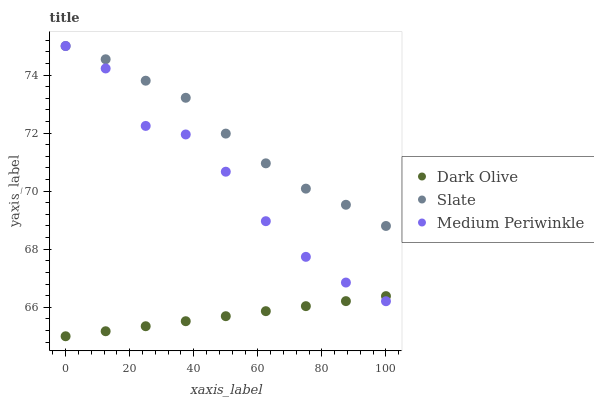Does Dark Olive have the minimum area under the curve?
Answer yes or no. Yes. Does Slate have the maximum area under the curve?
Answer yes or no. Yes. Does Medium Periwinkle have the minimum area under the curve?
Answer yes or no. No. Does Medium Periwinkle have the maximum area under the curve?
Answer yes or no. No. Is Dark Olive the smoothest?
Answer yes or no. Yes. Is Medium Periwinkle the roughest?
Answer yes or no. Yes. Is Medium Periwinkle the smoothest?
Answer yes or no. No. Is Dark Olive the roughest?
Answer yes or no. No. Does Dark Olive have the lowest value?
Answer yes or no. Yes. Does Medium Periwinkle have the lowest value?
Answer yes or no. No. Does Medium Periwinkle have the highest value?
Answer yes or no. Yes. Does Dark Olive have the highest value?
Answer yes or no. No. Is Dark Olive less than Slate?
Answer yes or no. Yes. Is Slate greater than Dark Olive?
Answer yes or no. Yes. Does Dark Olive intersect Medium Periwinkle?
Answer yes or no. Yes. Is Dark Olive less than Medium Periwinkle?
Answer yes or no. No. Is Dark Olive greater than Medium Periwinkle?
Answer yes or no. No. Does Dark Olive intersect Slate?
Answer yes or no. No. 